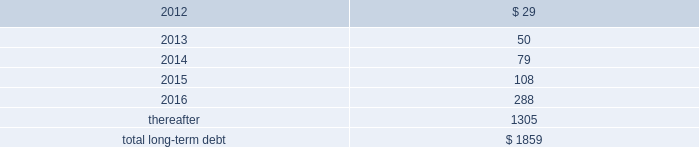Performance of the company 2019s obligations under the senior notes , including any repurchase obligations resulting from a change of control , is unconditionally guaranteed , jointly and severally , on an unsecured basis , by each of hii 2019s existing and future domestic restricted subsidiaries that guarantees debt under the credit facility ( the 201csubsidiary guarantors 201d ) .
The guarantees rank equally with all other unsecured and unsubordinated indebtedness of the guarantors .
The subsidiary guarantors are each directly or indirectly 100% ( 100 % ) owned by hii .
There are no significant restrictions on the ability of hii or any subsidiary guarantor to obtain funds from their respective subsidiaries by dividend or loan .
Mississippi economic development revenue bonds 2014as of december 31 , 2011 and 2010 , the company had $ 83.7 million outstanding from the issuance of industrial revenue bonds issued by the mississippi business finance corporation .
These bonds accrue interest at a fixed rate of 7.81% ( 7.81 % ) per annum ( payable semi-annually ) and mature in 2024 .
While repayment of principal and interest is guaranteed by northrop grumman systems corporation , hii has agreed to indemnify northrop grumman systems corporation for any losses related to the guaranty .
In accordance with the terms of the bonds , the proceeds have been used to finance the construction , reconstruction , and renovation of the company 2019s interest in certain ship manufacturing and repair facilities , or portions thereof , located in the state of mississippi .
Gulf opportunity zone industrial development revenue bonds 2014as of december 31 , 2011 and 2010 , the company had $ 21.6 million outstanding from the issuance of gulf opportunity zone industrial development revenue bonds ( 201cgo zone irbs 201d ) issued by the mississippi business finance corporation .
The go zone irbs were initially issued in a principal amount of $ 200 million , and in november 2010 , in connection with the anticipated spin-off , hii purchased $ 178 million of the bonds using the proceeds from a $ 178 million intercompany loan from northrop grumman .
See note 20 : related party transactions and former parent company equity .
The remaining bonds accrue interest at a fixed rate of 4.55% ( 4.55 % ) per annum ( payable semi-annually ) , and mature in 2028 .
In accordance with the terms of the bonds , the proceeds have been used to finance the construction , reconstruction , and renovation of the company 2019s interest in certain ship manufacturing and repair facilities , or portions thereof , located in the state of mississippi .
The estimated fair value of the company 2019s total long-term debt , including current portions , at december 31 , 2011 and 2010 , was $ 1864 million and $ 128 million , respectively .
The fair value of the total long-term debt was calculated based on recent trades for most of the company 2019s debt instruments or based on interest rates prevailing on debt with substantially similar risks , terms and maturities .
The aggregate amounts of principal payments due on long-term debt for each of the next five years and thereafter are : ( $ in millions ) .
14 .
Investigations , claims , and litigation the company is involved in legal proceedings before various courts and administrative agencies , and is periodically subject to government examinations , inquiries and investigations .
Pursuant to fasb accounting standard codification 450 contingencies , the company has accrued for losses associated with investigations , claims and litigation when , and to the extent that , loss amounts related to the investigations , claims and litigation are probable and can be reasonably estimated .
The actual losses that might be incurred to resolve such investigations , claims and litigation may be higher or lower than the amounts accrued .
For matters where a material loss is probable or reasonably possible and the amount of loss cannot be reasonably estimated , but the company is able to reasonably estimate a range of possible losses , such estimated range is required to be disclosed in these notes .
This estimated range would be based on information currently available to the company and would involve elements of judgment and significant uncertainties .
This estimated range of possible loss would not represent the company 2019s maximum possible loss exposure .
For matters as to which the company is not able to reasonably estimate a possible loss or range of loss , the company is required to indicate the reasons why it is unable to estimate the possible loss or range of loss .
For matters not specifically described in these notes , the company does not believe , based on information currently available to it , that it is reasonably possible that the liabilities , if any , arising from .
What is the ratio of the long-term debt after 2016 to the total long term debt? 
Rationale: the ratio of the long term debt after 2016 to the total long term debt means that for every $ 1 of the total long term debt is made up of $ 0.70 of long term debt due after 2016
Computations: (1305 / 1859)
Answer: 0.70199. 